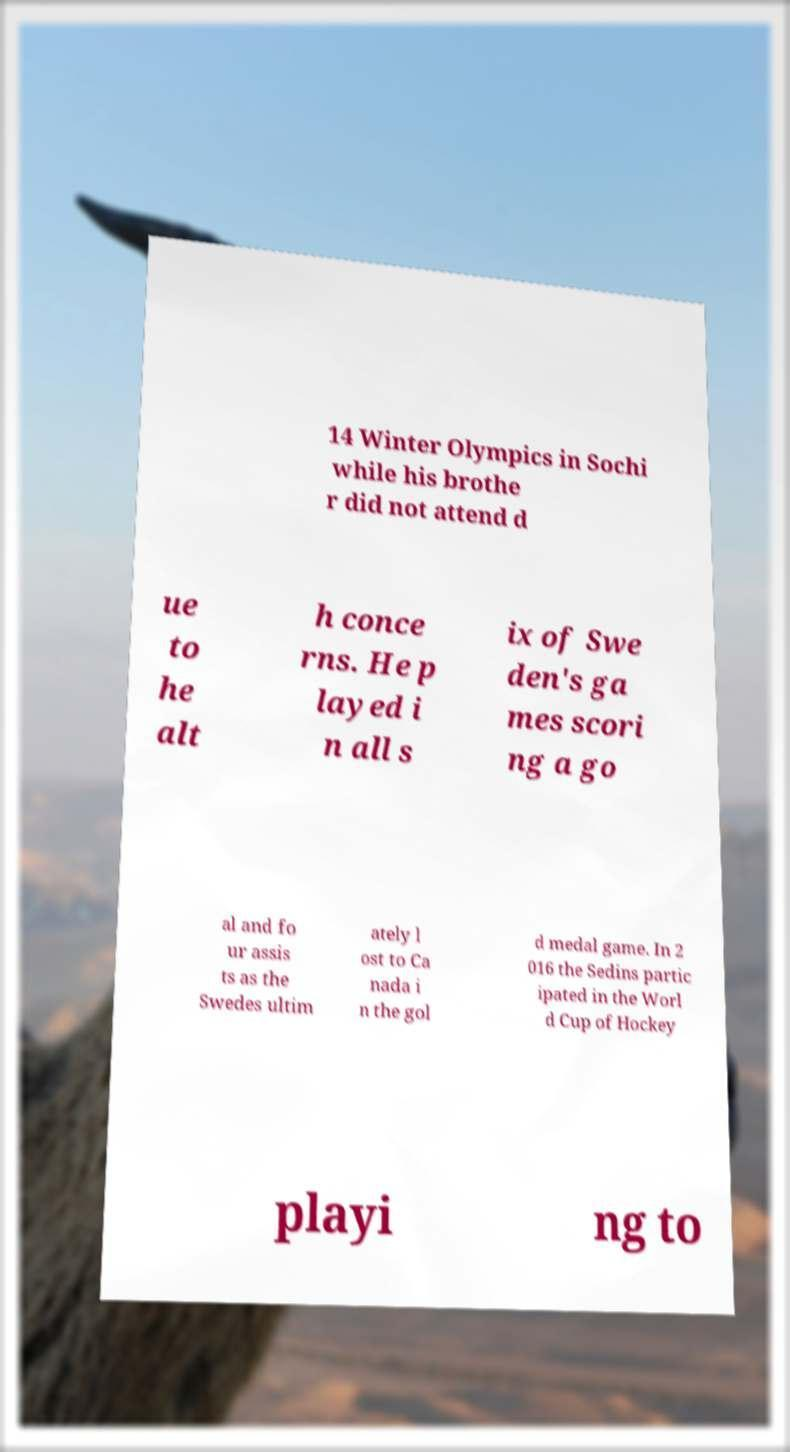Can you accurately transcribe the text from the provided image for me? 14 Winter Olympics in Sochi while his brothe r did not attend d ue to he alt h conce rns. He p layed i n all s ix of Swe den's ga mes scori ng a go al and fo ur assis ts as the Swedes ultim ately l ost to Ca nada i n the gol d medal game. In 2 016 the Sedins partic ipated in the Worl d Cup of Hockey playi ng to 